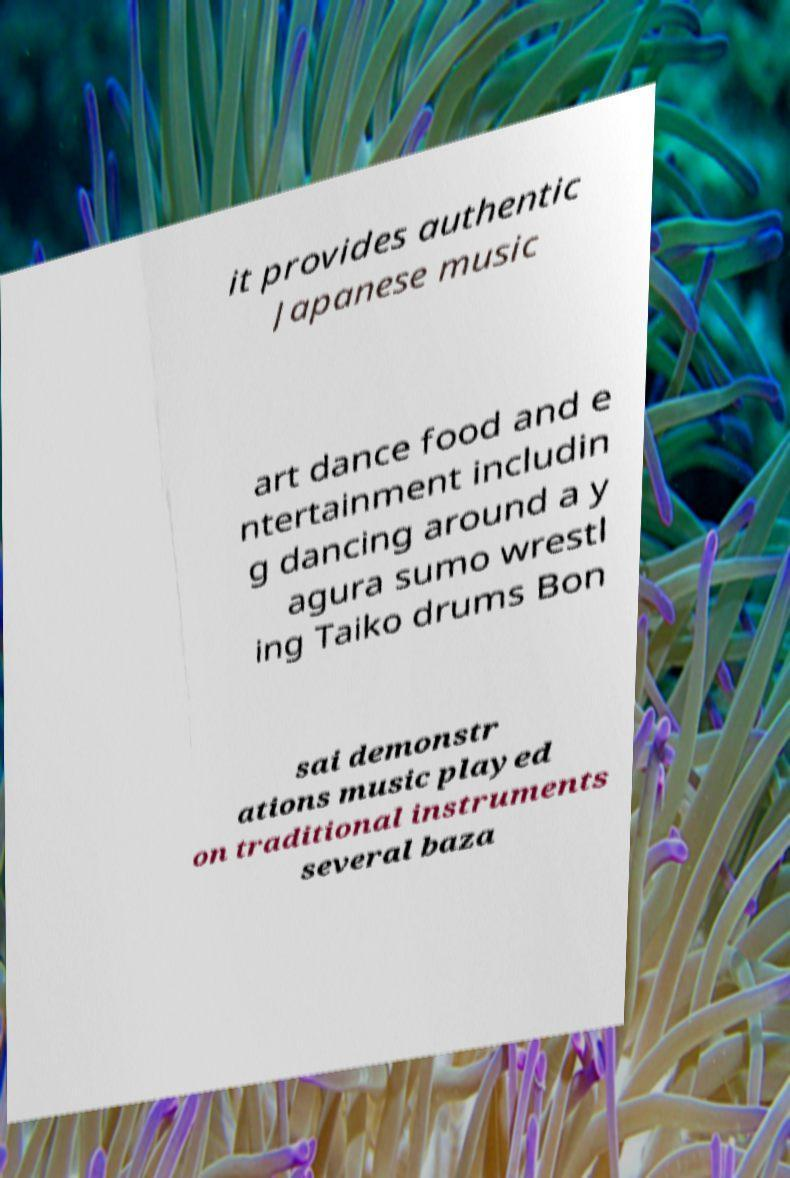For documentation purposes, I need the text within this image transcribed. Could you provide that? it provides authentic Japanese music art dance food and e ntertainment includin g dancing around a y agura sumo wrestl ing Taiko drums Bon sai demonstr ations music played on traditional instruments several baza 